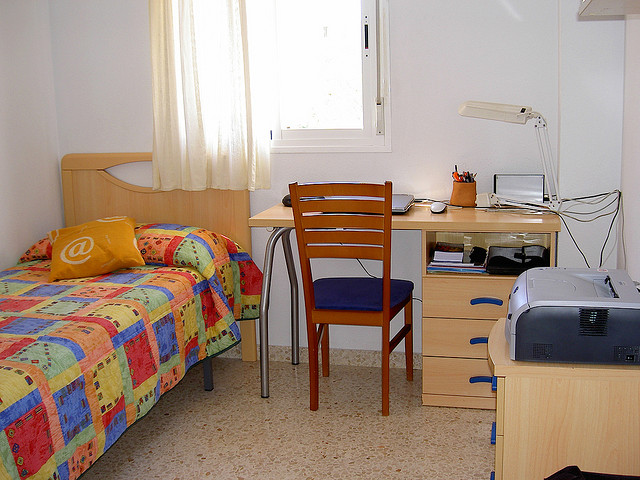Please transcribe the text information in this image. @ 